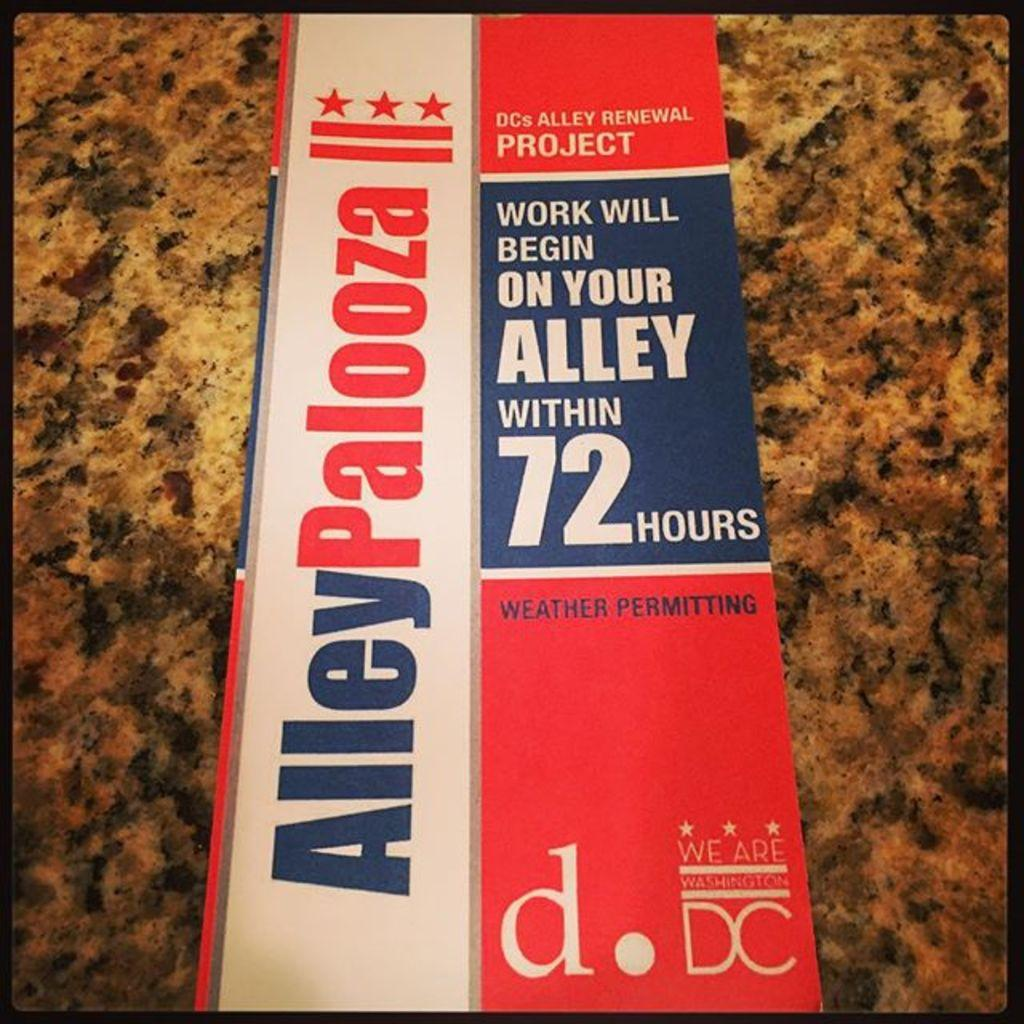What object can be seen in the image? There is a book in the image. Where is the book located? The book is placed on a table. What type of steel is used to construct the building in the image? There is no building present in the image, so it is not possible to determine the type of steel used in its construction. 